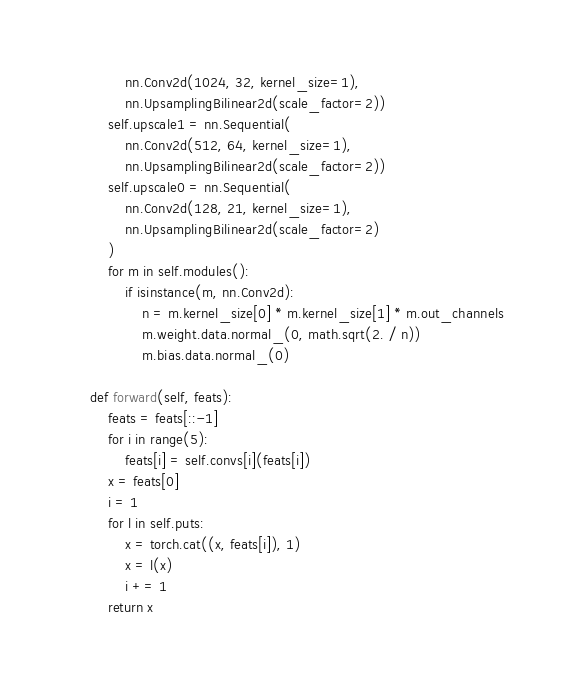Convert code to text. <code><loc_0><loc_0><loc_500><loc_500><_Python_>            nn.Conv2d(1024, 32, kernel_size=1),
            nn.UpsamplingBilinear2d(scale_factor=2))
        self.upscale1 = nn.Sequential(
            nn.Conv2d(512, 64, kernel_size=1),
            nn.UpsamplingBilinear2d(scale_factor=2))
        self.upscale0 = nn.Sequential(
            nn.Conv2d(128, 21, kernel_size=1),
            nn.UpsamplingBilinear2d(scale_factor=2)
        )
        for m in self.modules():
            if isinstance(m, nn.Conv2d):
                n = m.kernel_size[0] * m.kernel_size[1] * m.out_channels
                m.weight.data.normal_(0, math.sqrt(2. / n))
                m.bias.data.normal_(0)

    def forward(self, feats):
        feats = feats[::-1]
        for i in range(5):
            feats[i] = self.convs[i](feats[i])
        x = feats[0]
        i = 1
        for l in self.puts:
            x = torch.cat((x, feats[i]), 1)
            x = l(x)
            i += 1
        return x</code> 